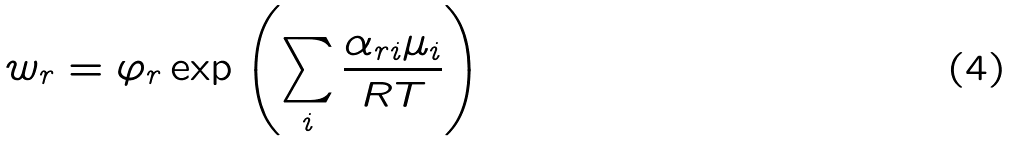Convert formula to latex. <formula><loc_0><loc_0><loc_500><loc_500>w _ { r } = \varphi _ { r } \exp \left ( \sum _ { i } { \frac { \alpha _ { r i } \mu _ { i } } { R T } } \right )</formula> 